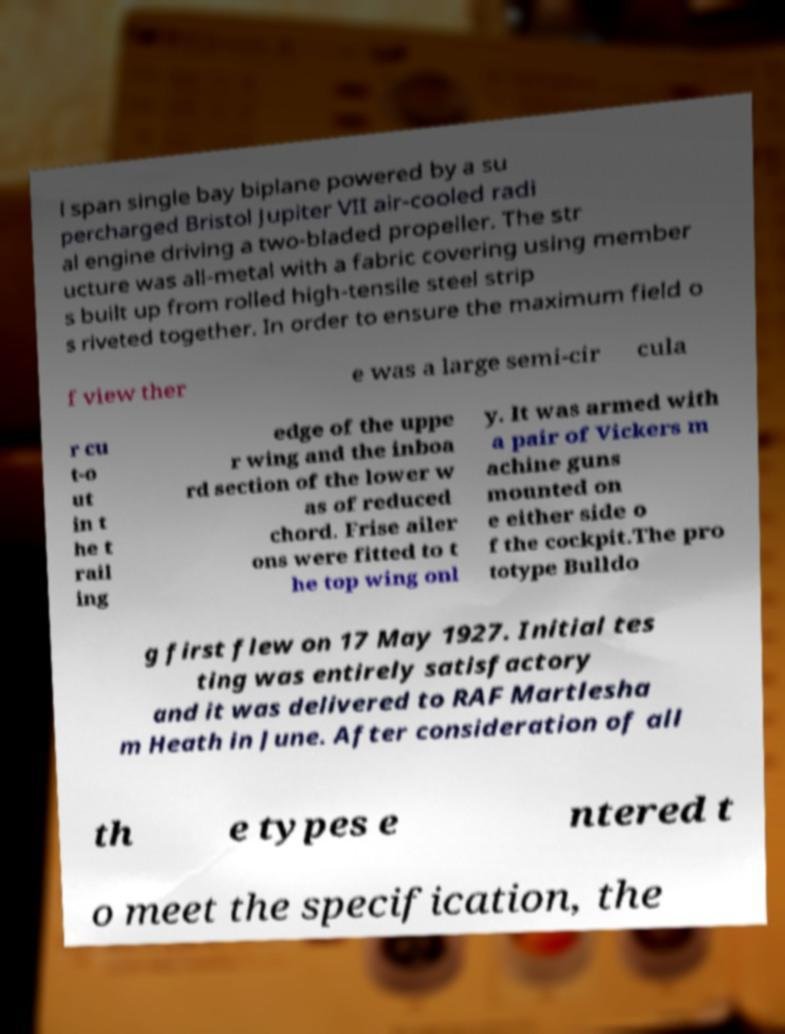Could you assist in decoding the text presented in this image and type it out clearly? l span single bay biplane powered by a su percharged Bristol Jupiter VII air-cooled radi al engine driving a two-bladed propeller. The str ucture was all-metal with a fabric covering using member s built up from rolled high-tensile steel strip s riveted together. In order to ensure the maximum field o f view ther e was a large semi-cir cula r cu t-o ut in t he t rail ing edge of the uppe r wing and the inboa rd section of the lower w as of reduced chord. Frise ailer ons were fitted to t he top wing onl y. It was armed with a pair of Vickers m achine guns mounted on e either side o f the cockpit.The pro totype Bulldo g first flew on 17 May 1927. Initial tes ting was entirely satisfactory and it was delivered to RAF Martlesha m Heath in June. After consideration of all th e types e ntered t o meet the specification, the 